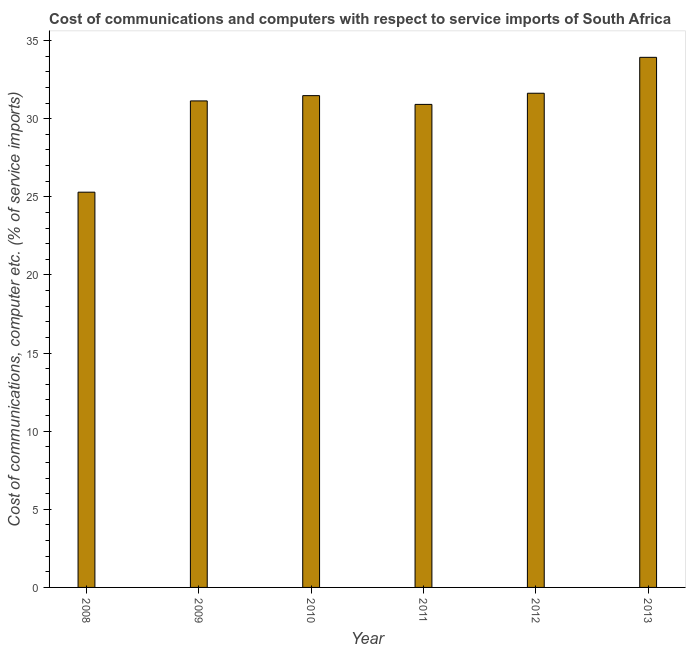Does the graph contain any zero values?
Ensure brevity in your answer.  No. What is the title of the graph?
Provide a succinct answer. Cost of communications and computers with respect to service imports of South Africa. What is the label or title of the X-axis?
Your answer should be very brief. Year. What is the label or title of the Y-axis?
Offer a terse response. Cost of communications, computer etc. (% of service imports). What is the cost of communications and computer in 2013?
Provide a short and direct response. 33.92. Across all years, what is the maximum cost of communications and computer?
Offer a terse response. 33.92. Across all years, what is the minimum cost of communications and computer?
Ensure brevity in your answer.  25.29. What is the sum of the cost of communications and computer?
Provide a short and direct response. 184.37. What is the difference between the cost of communications and computer in 2009 and 2011?
Keep it short and to the point. 0.22. What is the average cost of communications and computer per year?
Your answer should be very brief. 30.73. What is the median cost of communications and computer?
Your answer should be very brief. 31.3. Do a majority of the years between 2008 and 2009 (inclusive) have cost of communications and computer greater than 34 %?
Provide a succinct answer. No. What is the ratio of the cost of communications and computer in 2008 to that in 2010?
Provide a short and direct response. 0.8. Is the cost of communications and computer in 2011 less than that in 2012?
Your answer should be compact. Yes. What is the difference between the highest and the second highest cost of communications and computer?
Your answer should be compact. 2.3. Is the sum of the cost of communications and computer in 2009 and 2013 greater than the maximum cost of communications and computer across all years?
Give a very brief answer. Yes. What is the difference between the highest and the lowest cost of communications and computer?
Keep it short and to the point. 8.63. How many bars are there?
Ensure brevity in your answer.  6. Are all the bars in the graph horizontal?
Your response must be concise. No. What is the difference between two consecutive major ticks on the Y-axis?
Give a very brief answer. 5. Are the values on the major ticks of Y-axis written in scientific E-notation?
Offer a terse response. No. What is the Cost of communications, computer etc. (% of service imports) of 2008?
Your response must be concise. 25.29. What is the Cost of communications, computer etc. (% of service imports) in 2009?
Offer a very short reply. 31.14. What is the Cost of communications, computer etc. (% of service imports) in 2010?
Make the answer very short. 31.47. What is the Cost of communications, computer etc. (% of service imports) in 2011?
Give a very brief answer. 30.91. What is the Cost of communications, computer etc. (% of service imports) of 2012?
Your answer should be compact. 31.63. What is the Cost of communications, computer etc. (% of service imports) of 2013?
Your response must be concise. 33.92. What is the difference between the Cost of communications, computer etc. (% of service imports) in 2008 and 2009?
Your answer should be compact. -5.84. What is the difference between the Cost of communications, computer etc. (% of service imports) in 2008 and 2010?
Make the answer very short. -6.18. What is the difference between the Cost of communications, computer etc. (% of service imports) in 2008 and 2011?
Provide a short and direct response. -5.62. What is the difference between the Cost of communications, computer etc. (% of service imports) in 2008 and 2012?
Give a very brief answer. -6.33. What is the difference between the Cost of communications, computer etc. (% of service imports) in 2008 and 2013?
Your response must be concise. -8.63. What is the difference between the Cost of communications, computer etc. (% of service imports) in 2009 and 2010?
Your answer should be very brief. -0.34. What is the difference between the Cost of communications, computer etc. (% of service imports) in 2009 and 2011?
Provide a succinct answer. 0.22. What is the difference between the Cost of communications, computer etc. (% of service imports) in 2009 and 2012?
Provide a succinct answer. -0.49. What is the difference between the Cost of communications, computer etc. (% of service imports) in 2009 and 2013?
Offer a terse response. -2.79. What is the difference between the Cost of communications, computer etc. (% of service imports) in 2010 and 2011?
Ensure brevity in your answer.  0.56. What is the difference between the Cost of communications, computer etc. (% of service imports) in 2010 and 2012?
Keep it short and to the point. -0.15. What is the difference between the Cost of communications, computer etc. (% of service imports) in 2010 and 2013?
Provide a short and direct response. -2.45. What is the difference between the Cost of communications, computer etc. (% of service imports) in 2011 and 2012?
Your answer should be compact. -0.71. What is the difference between the Cost of communications, computer etc. (% of service imports) in 2011 and 2013?
Make the answer very short. -3.01. What is the difference between the Cost of communications, computer etc. (% of service imports) in 2012 and 2013?
Ensure brevity in your answer.  -2.3. What is the ratio of the Cost of communications, computer etc. (% of service imports) in 2008 to that in 2009?
Your answer should be very brief. 0.81. What is the ratio of the Cost of communications, computer etc. (% of service imports) in 2008 to that in 2010?
Provide a succinct answer. 0.8. What is the ratio of the Cost of communications, computer etc. (% of service imports) in 2008 to that in 2011?
Give a very brief answer. 0.82. What is the ratio of the Cost of communications, computer etc. (% of service imports) in 2008 to that in 2012?
Your answer should be compact. 0.8. What is the ratio of the Cost of communications, computer etc. (% of service imports) in 2008 to that in 2013?
Offer a very short reply. 0.75. What is the ratio of the Cost of communications, computer etc. (% of service imports) in 2009 to that in 2012?
Give a very brief answer. 0.98. What is the ratio of the Cost of communications, computer etc. (% of service imports) in 2009 to that in 2013?
Keep it short and to the point. 0.92. What is the ratio of the Cost of communications, computer etc. (% of service imports) in 2010 to that in 2011?
Your response must be concise. 1.02. What is the ratio of the Cost of communications, computer etc. (% of service imports) in 2010 to that in 2012?
Your answer should be very brief. 0.99. What is the ratio of the Cost of communications, computer etc. (% of service imports) in 2010 to that in 2013?
Provide a succinct answer. 0.93. What is the ratio of the Cost of communications, computer etc. (% of service imports) in 2011 to that in 2012?
Your answer should be very brief. 0.98. What is the ratio of the Cost of communications, computer etc. (% of service imports) in 2011 to that in 2013?
Offer a very short reply. 0.91. What is the ratio of the Cost of communications, computer etc. (% of service imports) in 2012 to that in 2013?
Give a very brief answer. 0.93. 